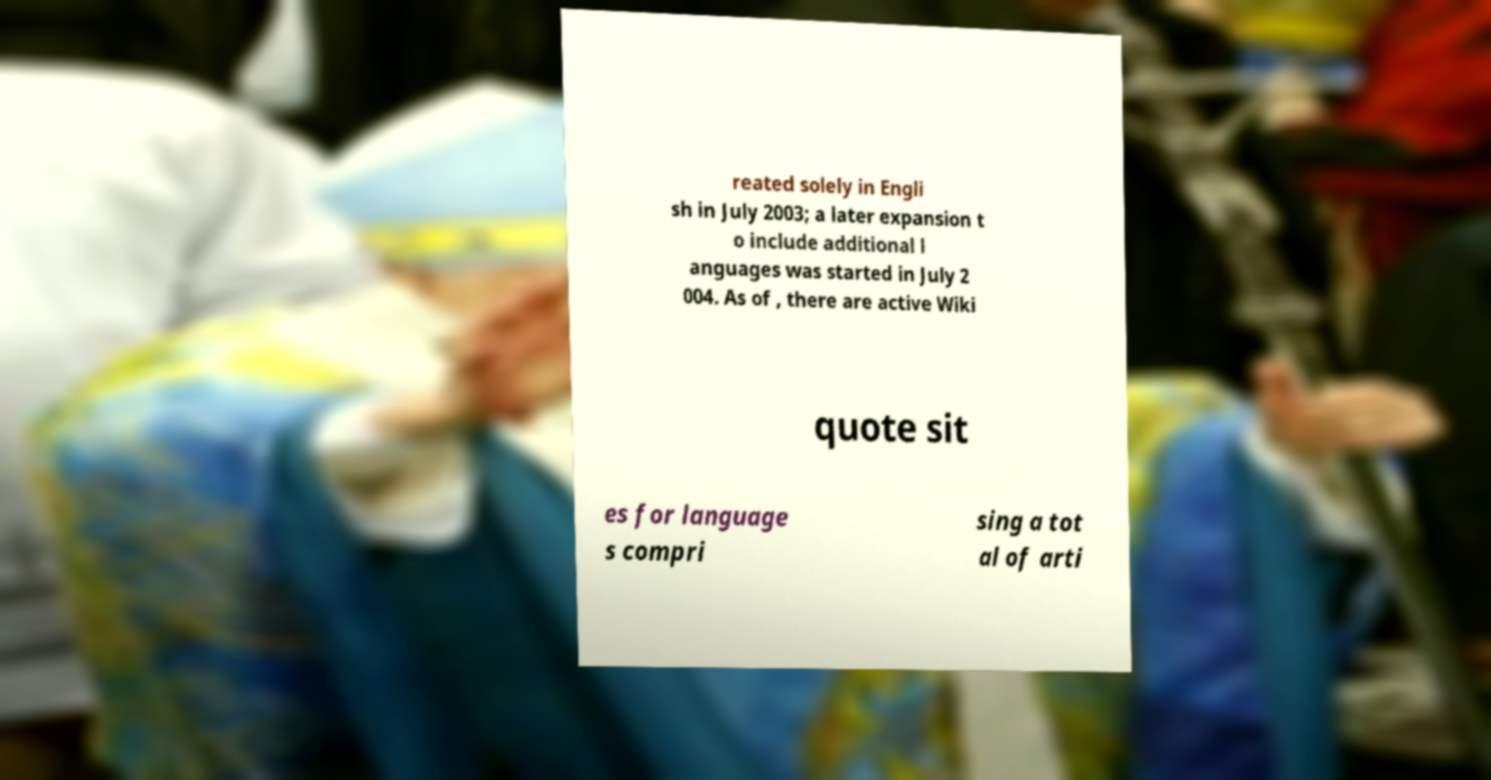There's text embedded in this image that I need extracted. Can you transcribe it verbatim? reated solely in Engli sh in July 2003; a later expansion t o include additional l anguages was started in July 2 004. As of , there are active Wiki quote sit es for language s compri sing a tot al of arti 